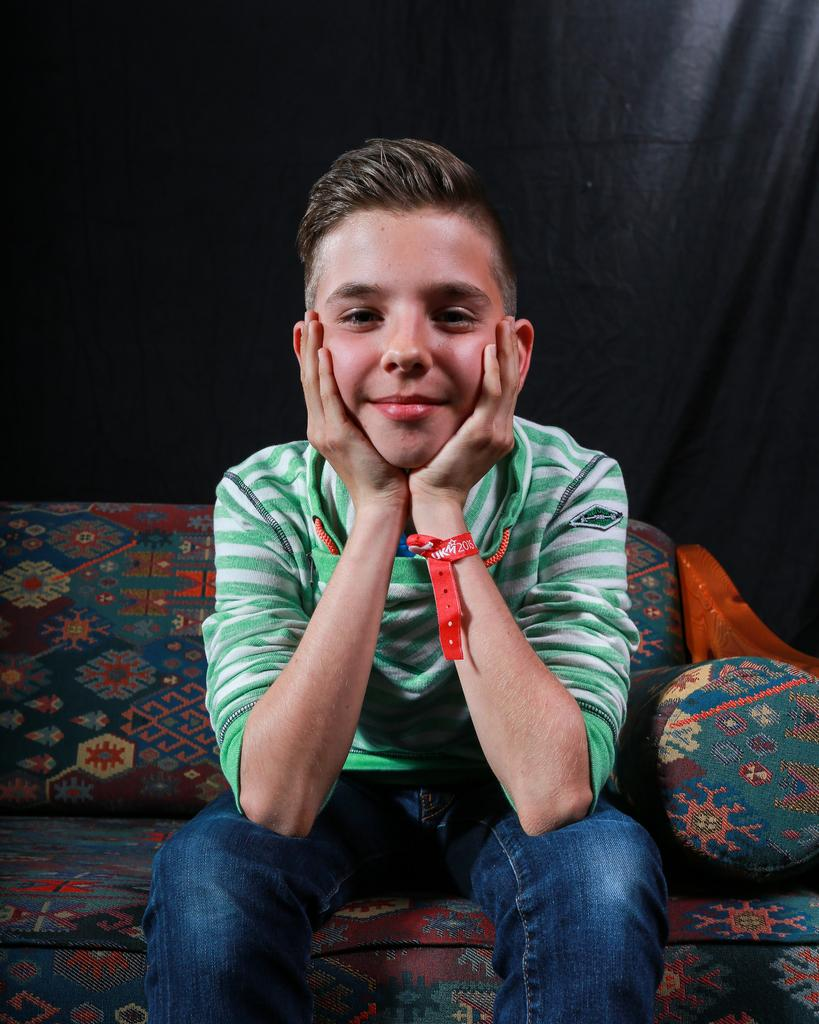Who is the main subject in the image? There is a boy in the image. What is the boy doing in the image? The boy is sitting on a sofa. What can be observed about the background of the image? The background of the image is dark. What type of sack is the boy carrying in the image? There is no sack present in the image; the boy is sitting on a sofa. What color is the boy's skin in the image? The provided facts do not mention the color of the boy's skin, and it cannot be determined from the image alone. 